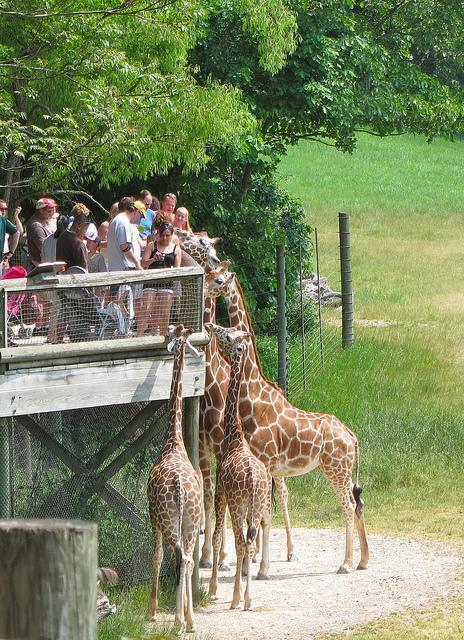Which giraffe left to right has the best chance of getting petted?
Pick the correct solution from the four options below to address the question.
Options: Second, very back, first, third one. Very back. 